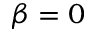Convert formula to latex. <formula><loc_0><loc_0><loc_500><loc_500>\beta = 0</formula> 